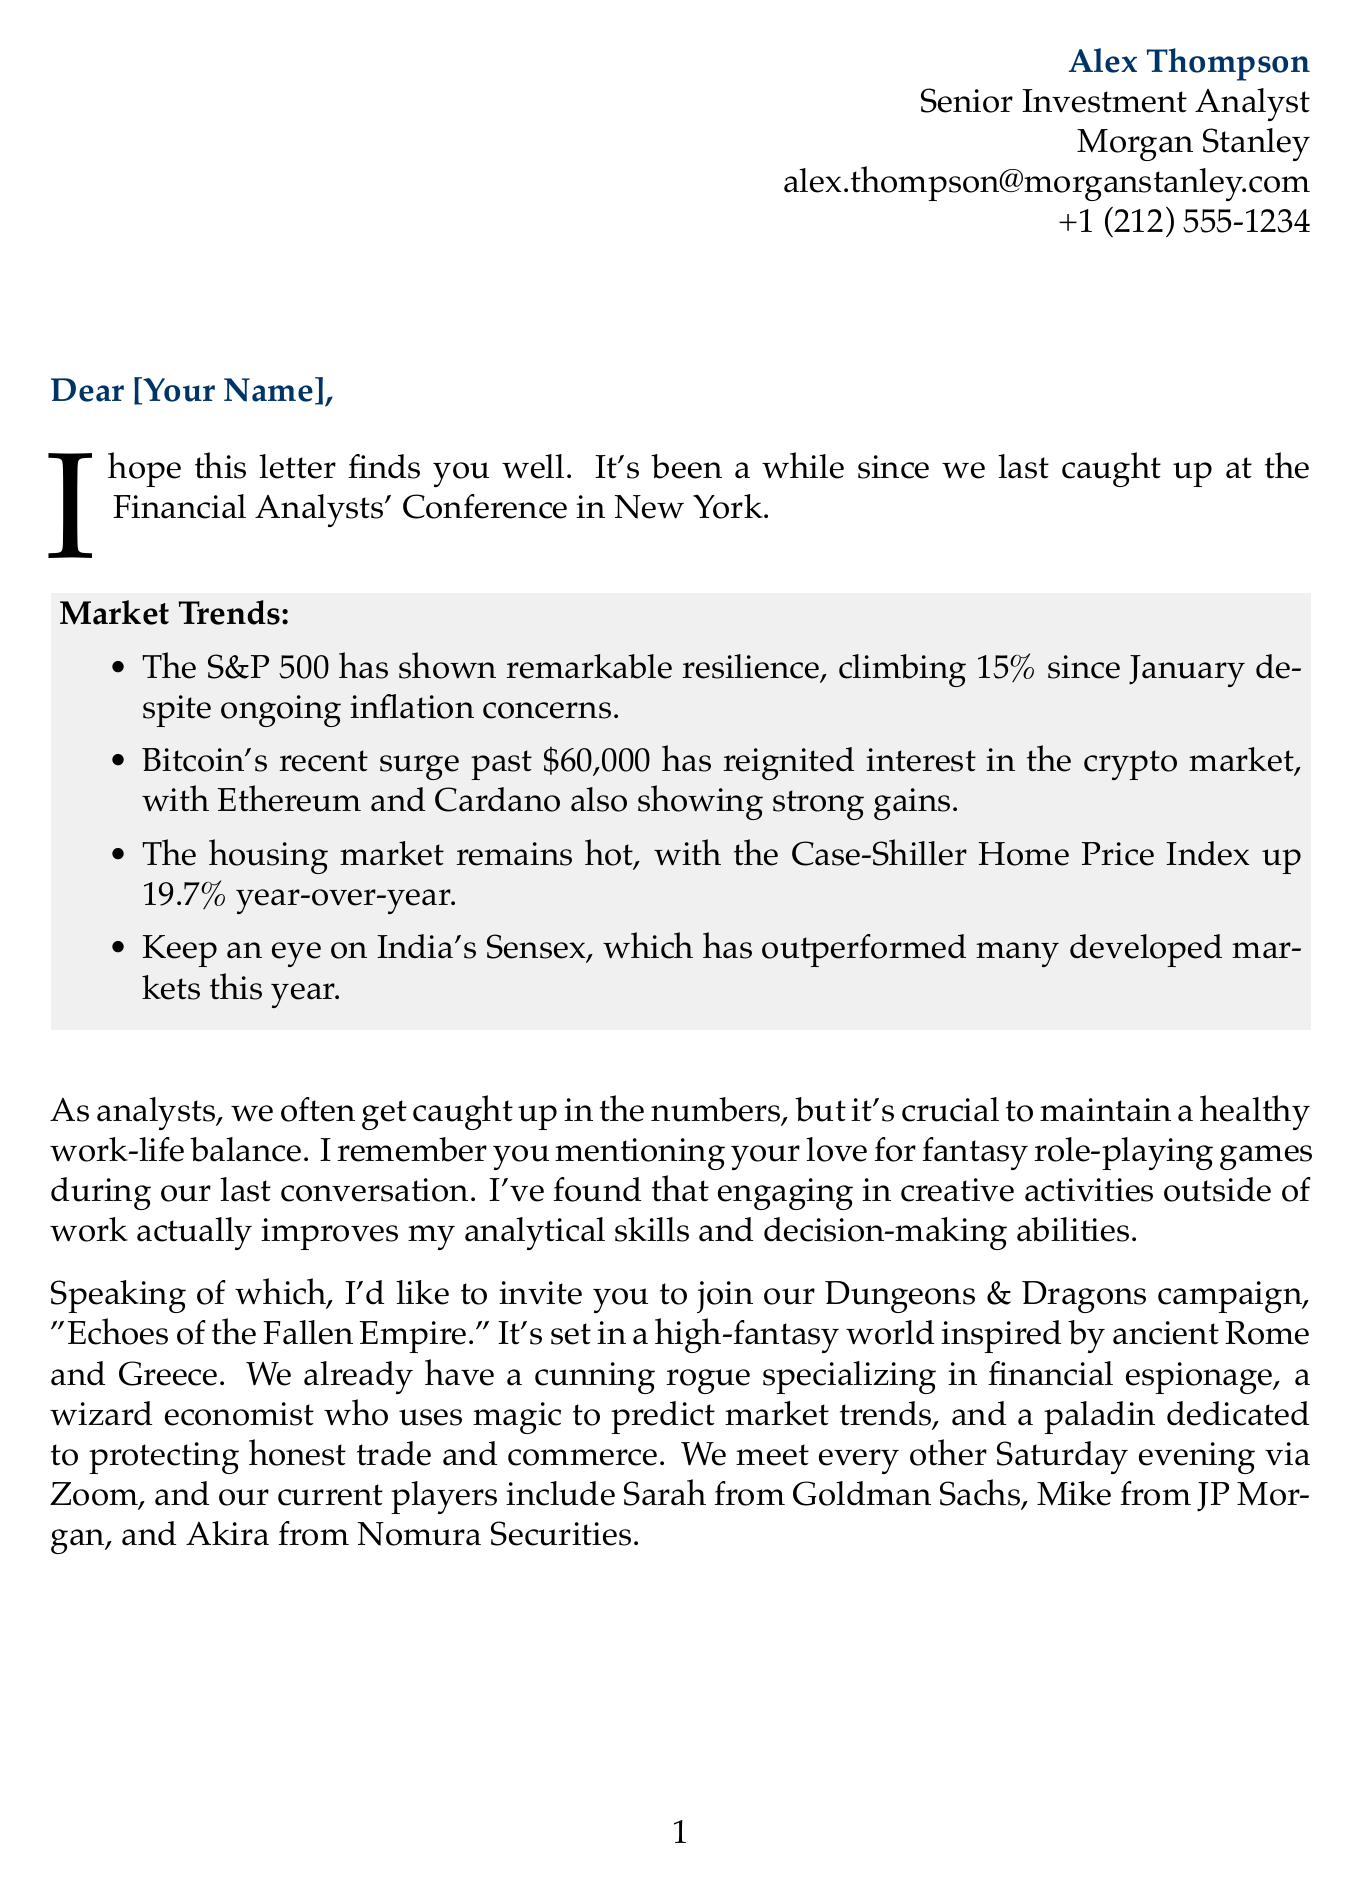What is the sender's name? The sender's name is presented in the letter as the author.
Answer: Alex Thompson What percentage has the S&P 500 climbed since January? This information is found in the market trends section discussing stock market performance.
Answer: 15% What is the name of the Dungeons & Dragons campaign? The campaign is mentioned specifically within the invitation section of the letter.
Answer: Echoes of the Fallen Empire How often do players meet for the D&D campaign? The frequency of meetings is detailed in the campaign invitation.
Answer: Every other Saturday evening Which character specializes in financial espionage? This detail is provided when listing the player characters in the D&D campaign.
Answer: A cunning rogue What is the current price of Bitcoin mentioned in the letter? The letter discusses Bitcoin’s price as part of the cryptocurrency market trends.
Answer: $60,000 What is the Case-Shiller Home Price Index increase year-over-year? This statistic is included in the real estate market trends section of the letter.
Answer: 19.7% What book is recommended to read? The letter includes a suggestion for further reading which connects to the investment analysis theme.
Answer: The Psychology of Money 